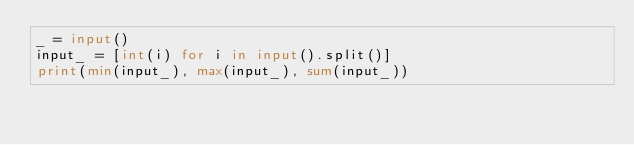Convert code to text. <code><loc_0><loc_0><loc_500><loc_500><_Python_>_ = input()
input_ = [int(i) for i in input().split()]
print(min(input_), max(input_), sum(input_))
</code> 